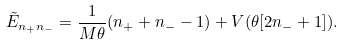Convert formula to latex. <formula><loc_0><loc_0><loc_500><loc_500>\tilde { E } _ { n _ { + } n _ { - } } = \frac { 1 } { M \theta } ( n _ { + } + n _ { - } - 1 ) + V ( \theta [ 2 n _ { - } + 1 ] ) .</formula> 